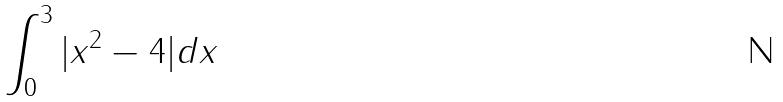<formula> <loc_0><loc_0><loc_500><loc_500>\int _ { 0 } ^ { 3 } | x ^ { 2 } - 4 | d x</formula> 